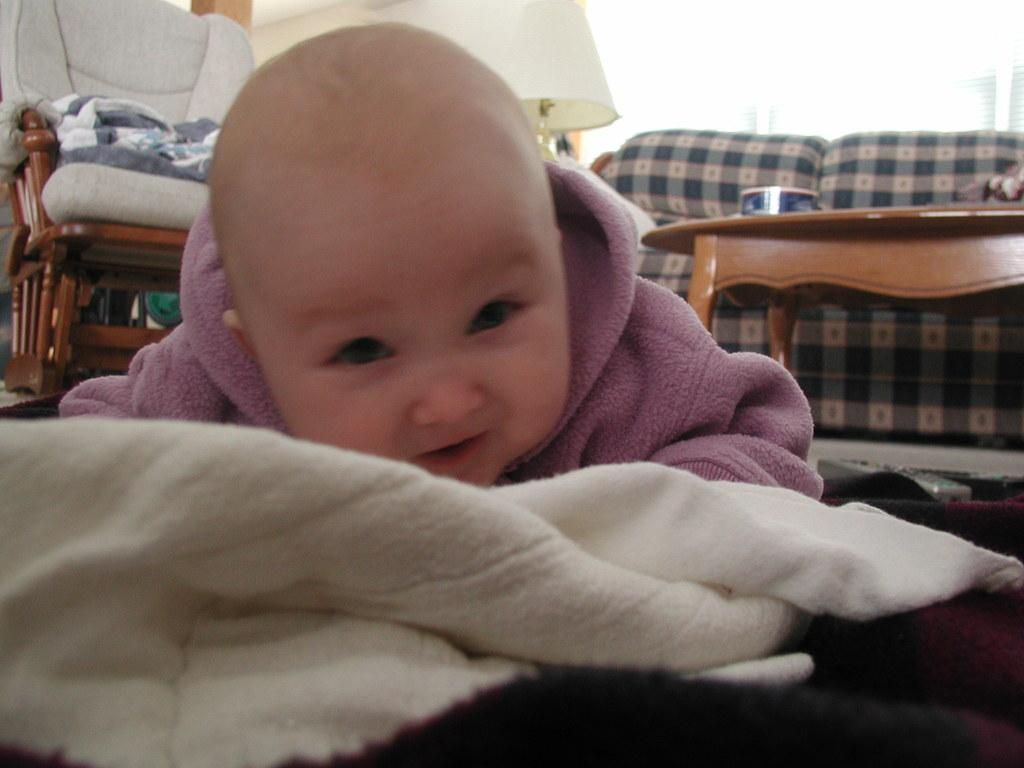What is the main subject of the image? There is a baby in the image. What is the baby's position in the image? The baby is lying on the ground. What is the baby wearing in the image? The baby is wearing a pink hoodie. What can be seen in the background of the image? There is a sofa and a table in the background of the image. Can you hear the baby's thoughts in the image? There is no indication in the image that we can hear the baby's thoughts, as the image is visual and not auditory. 